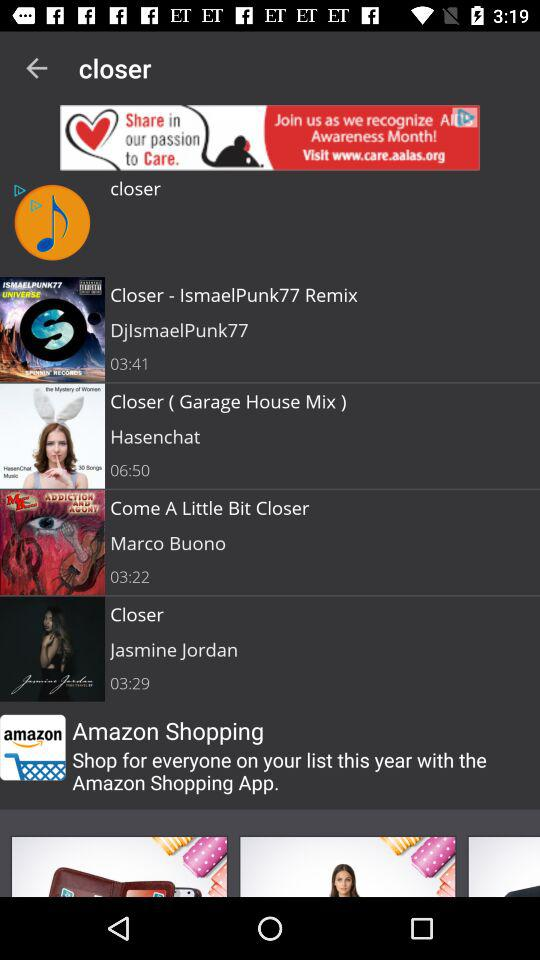Which song was sung by Hasenchat? Hasenchat sang "Closer ( Garage House Mix )". 